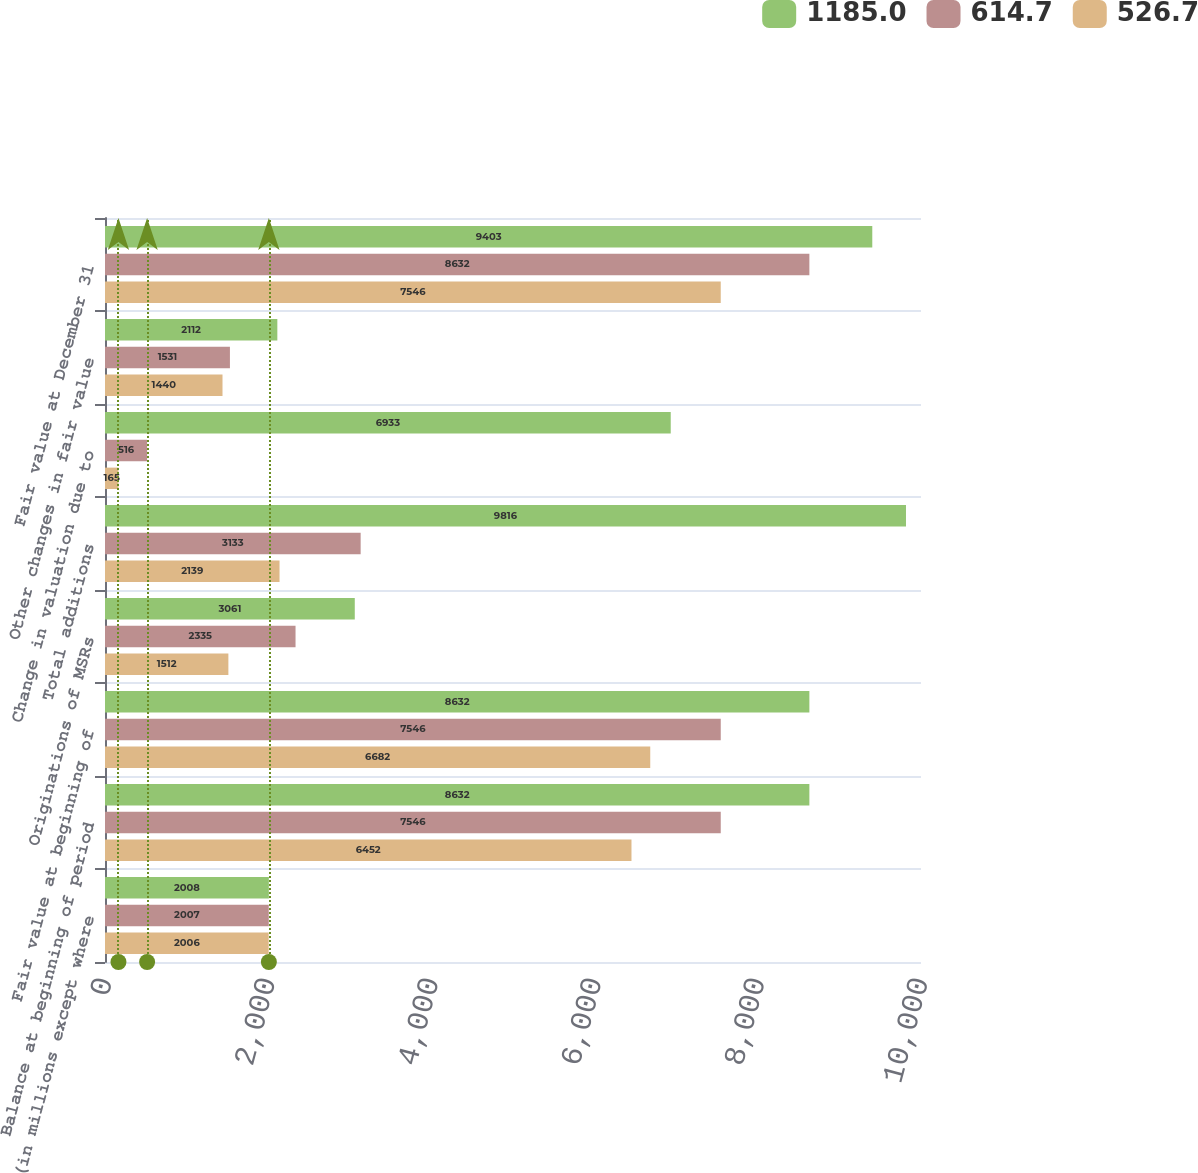Convert chart. <chart><loc_0><loc_0><loc_500><loc_500><stacked_bar_chart><ecel><fcel>(in millions except where<fcel>Balance at beginning of period<fcel>Fair value at beginning of<fcel>Originations of MSRs<fcel>Total additions<fcel>Change in valuation due to<fcel>Other changes in fair value<fcel>Fair value at December 31<nl><fcel>1185<fcel>2008<fcel>8632<fcel>8632<fcel>3061<fcel>9816<fcel>6933<fcel>2112<fcel>9403<nl><fcel>614.7<fcel>2007<fcel>7546<fcel>7546<fcel>2335<fcel>3133<fcel>516<fcel>1531<fcel>8632<nl><fcel>526.7<fcel>2006<fcel>6452<fcel>6682<fcel>1512<fcel>2139<fcel>165<fcel>1440<fcel>7546<nl></chart> 